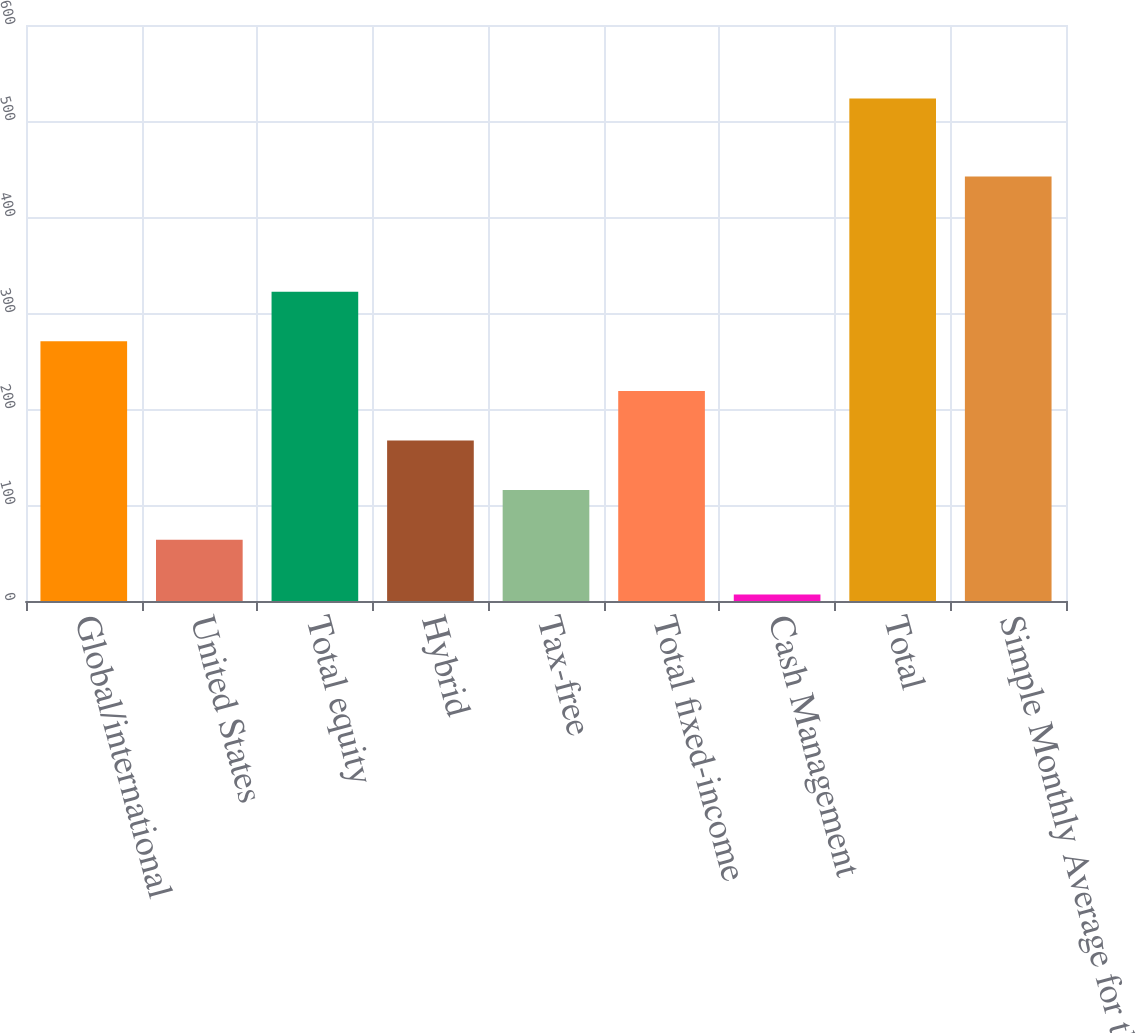Convert chart to OTSL. <chart><loc_0><loc_0><loc_500><loc_500><bar_chart><fcel>Global/international<fcel>United States<fcel>Total equity<fcel>Hybrid<fcel>Tax-free<fcel>Total fixed-income<fcel>Cash Management<fcel>Total<fcel>Simple Monthly Average for the<nl><fcel>270.5<fcel>63.9<fcel>322.15<fcel>167.2<fcel>115.55<fcel>218.85<fcel>6.9<fcel>523.4<fcel>442.2<nl></chart> 